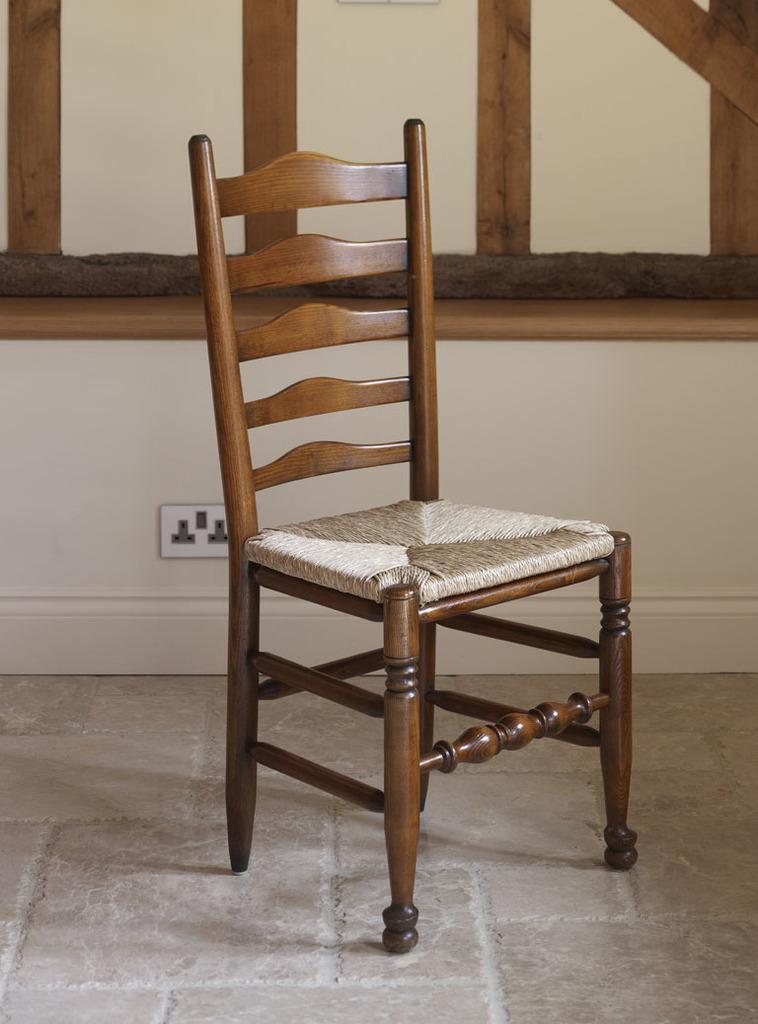Please provide a concise description of this image. In the middle of the image there is a chair placed on the floor. In the background there is a window to the wall and also a switch board is attached to the wall. 